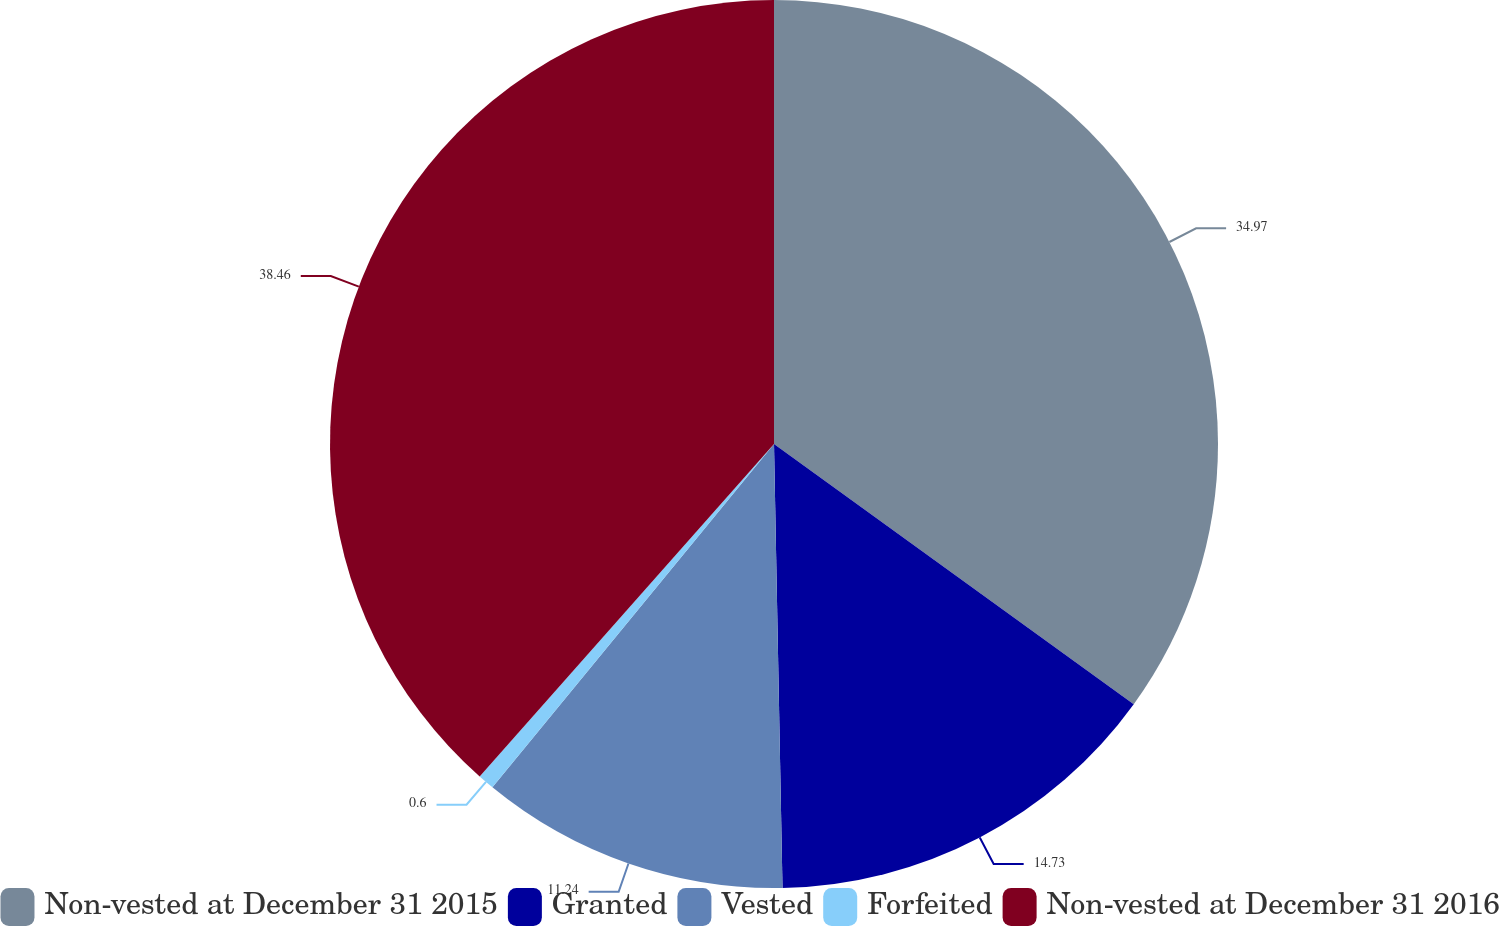Convert chart to OTSL. <chart><loc_0><loc_0><loc_500><loc_500><pie_chart><fcel>Non-vested at December 31 2015<fcel>Granted<fcel>Vested<fcel>Forfeited<fcel>Non-vested at December 31 2016<nl><fcel>34.97%<fcel>14.73%<fcel>11.24%<fcel>0.6%<fcel>38.47%<nl></chart> 